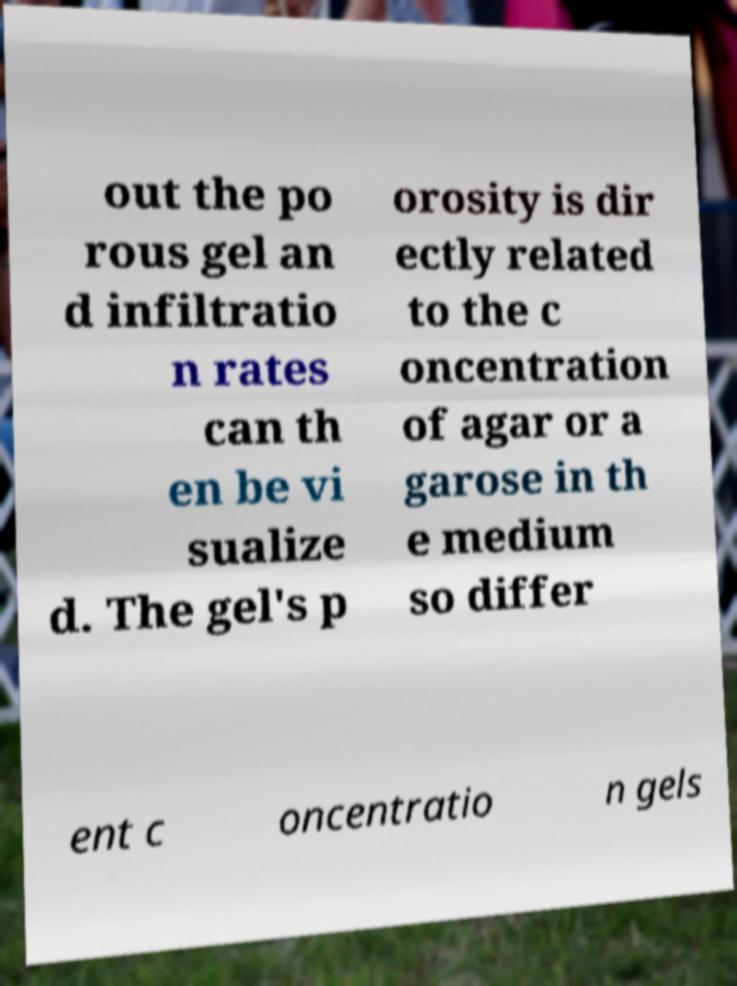There's text embedded in this image that I need extracted. Can you transcribe it verbatim? out the po rous gel an d infiltratio n rates can th en be vi sualize d. The gel's p orosity is dir ectly related to the c oncentration of agar or a garose in th e medium so differ ent c oncentratio n gels 